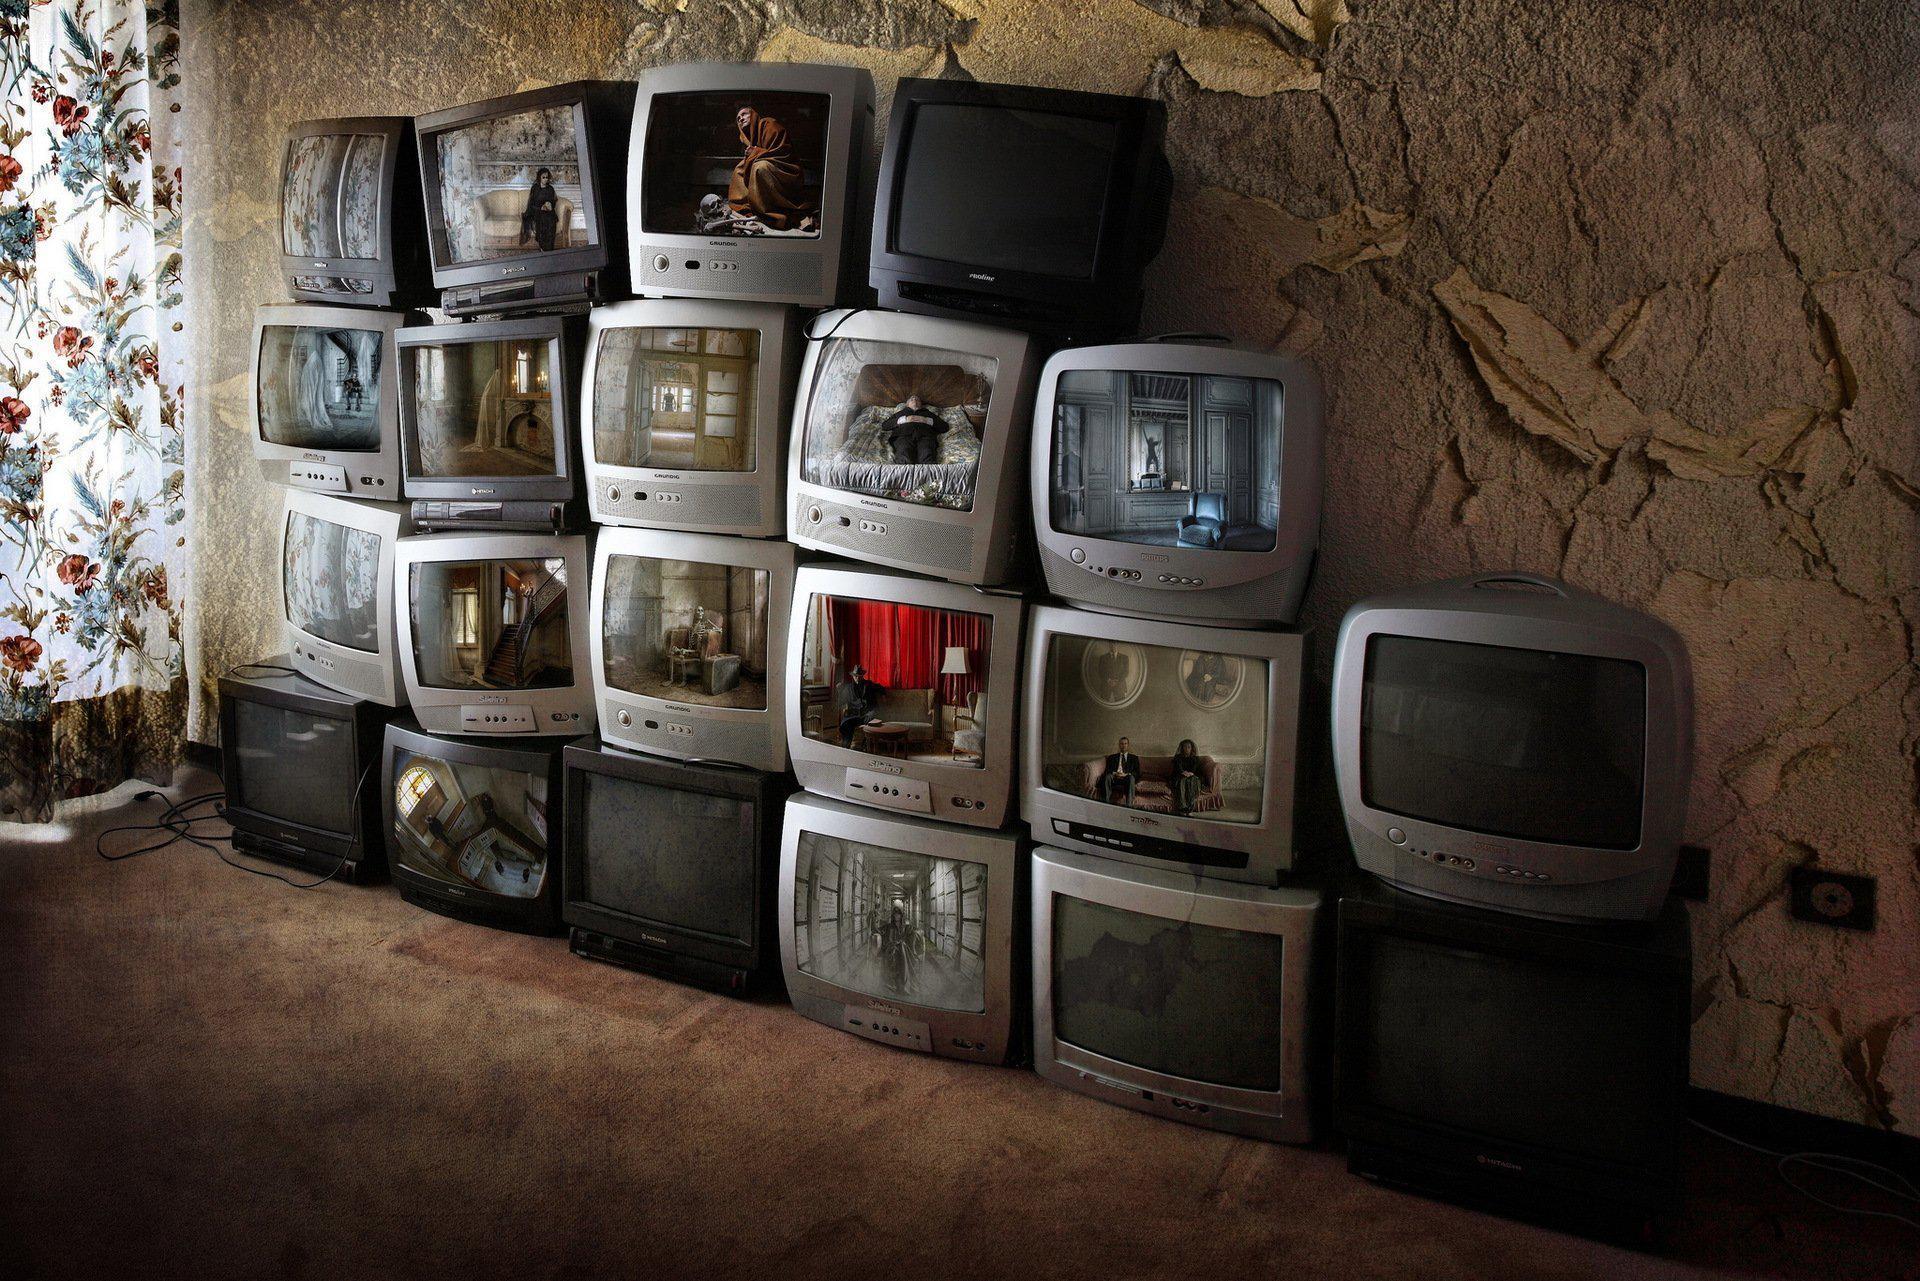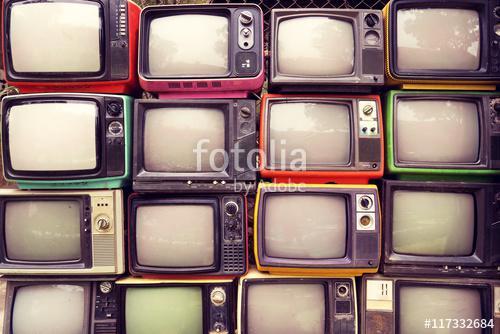The first image is the image on the left, the second image is the image on the right. Given the left and right images, does the statement "At least one image shows upholstered chairs situated behind TVs with illuminated screens." hold true? Answer yes or no. No. The first image is the image on the left, the second image is the image on the right. Given the left and right images, does the statement "Tube televisions are stacked together in the image on the left." hold true? Answer yes or no. Yes. 